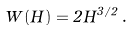<formula> <loc_0><loc_0><loc_500><loc_500>W ( H ) = 2 H ^ { 3 / 2 } \, .</formula> 